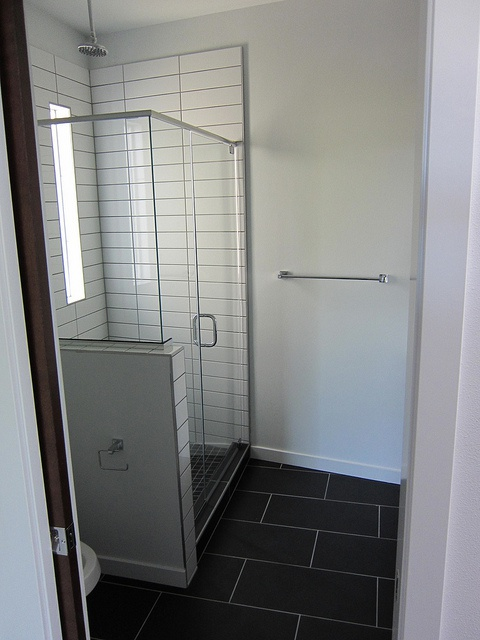Describe the objects in this image and their specific colors. I can see a toilet in black and gray tones in this image. 